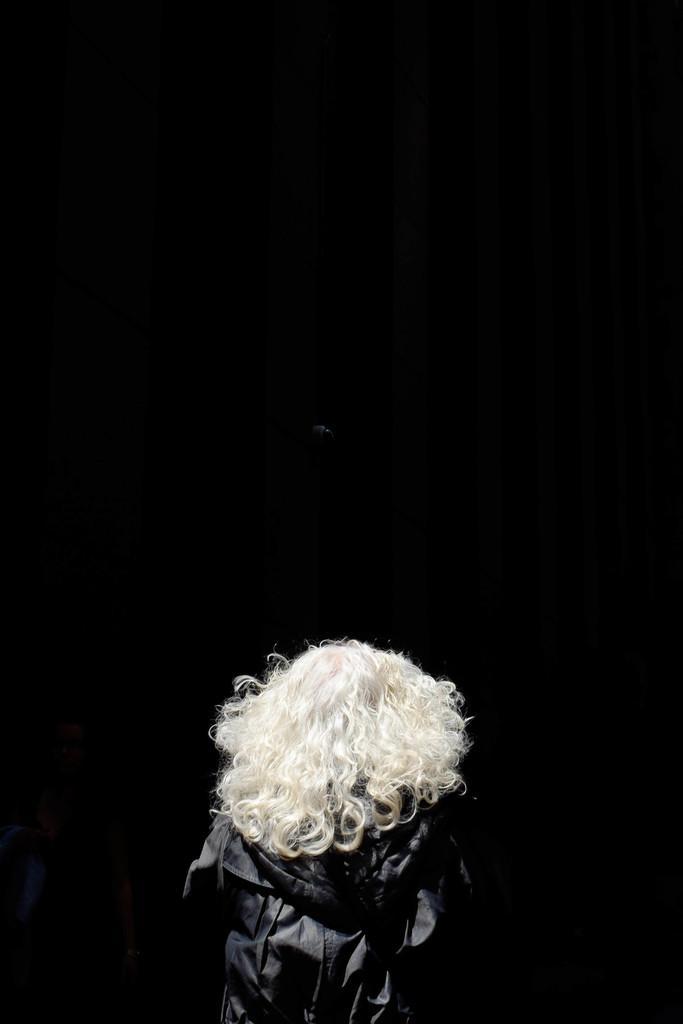How would you summarize this image in a sentence or two? This is the dark picture of a person with white hair is looking down. 